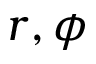Convert formula to latex. <formula><loc_0><loc_0><loc_500><loc_500>r , \phi</formula> 